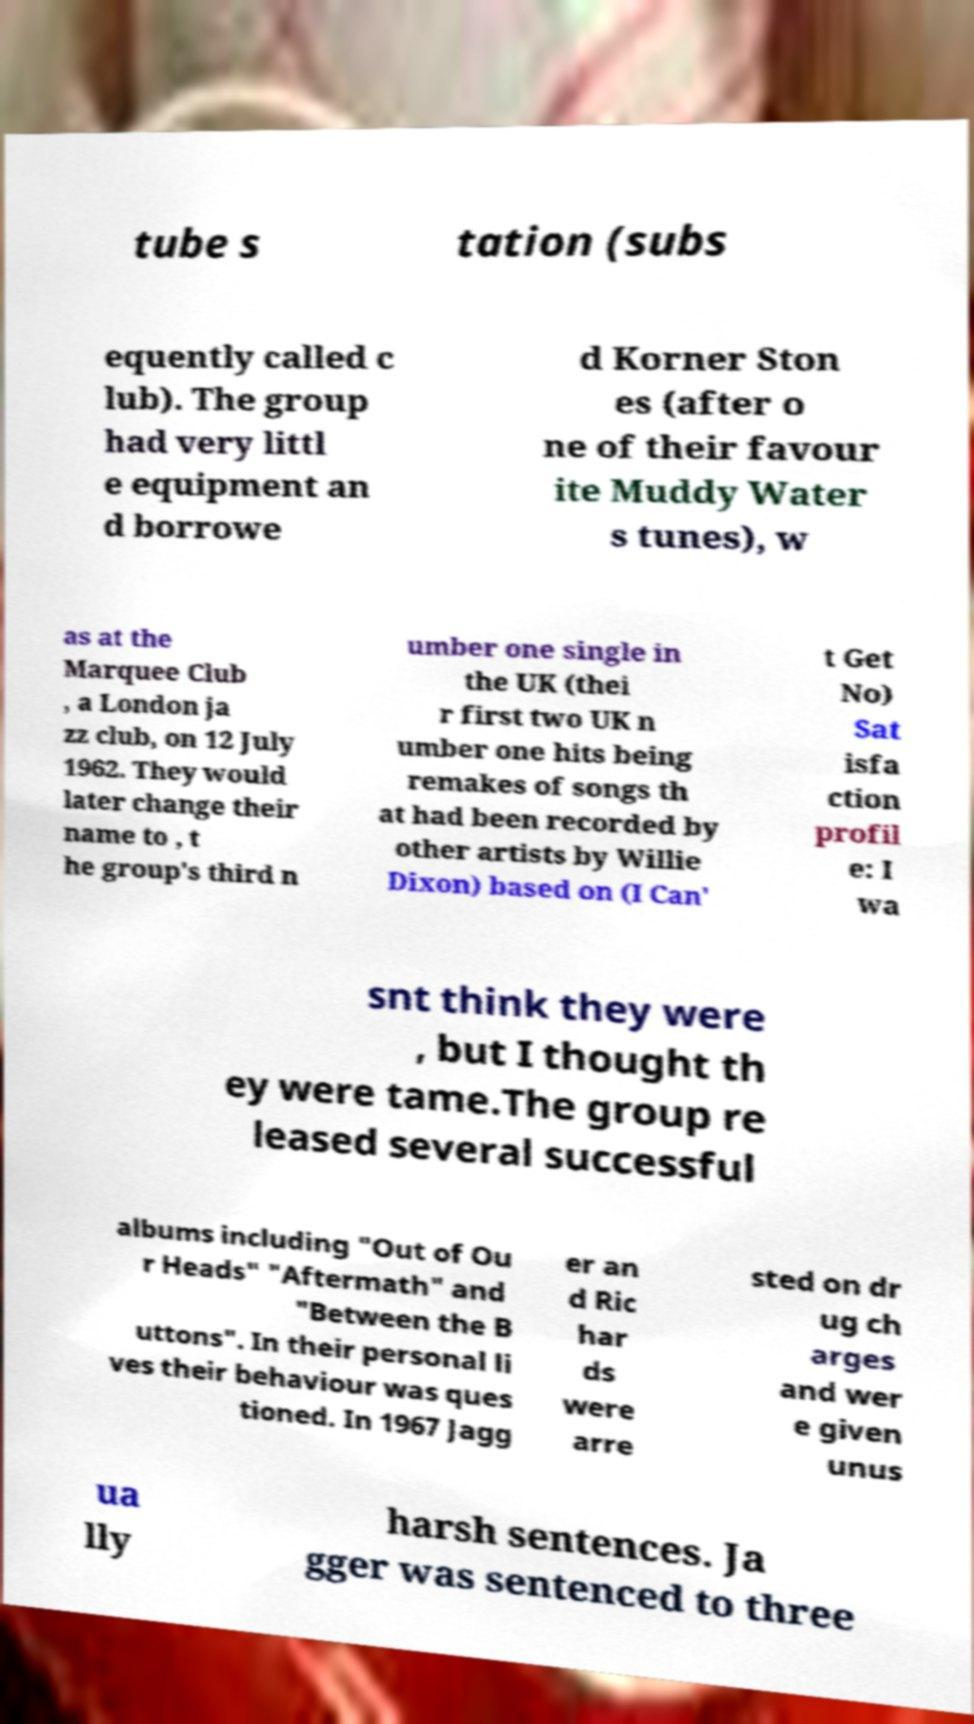Please identify and transcribe the text found in this image. tube s tation (subs equently called c lub). The group had very littl e equipment an d borrowe d Korner Ston es (after o ne of their favour ite Muddy Water s tunes), w as at the Marquee Club , a London ja zz club, on 12 July 1962. They would later change their name to , t he group's third n umber one single in the UK (thei r first two UK n umber one hits being remakes of songs th at had been recorded by other artists by Willie Dixon) based on (I Can' t Get No) Sat isfa ction profil e: I wa snt think they were , but I thought th ey were tame.The group re leased several successful albums including "Out of Ou r Heads" "Aftermath" and "Between the B uttons". In their personal li ves their behaviour was ques tioned. In 1967 Jagg er an d Ric har ds were arre sted on dr ug ch arges and wer e given unus ua lly harsh sentences. Ja gger was sentenced to three 